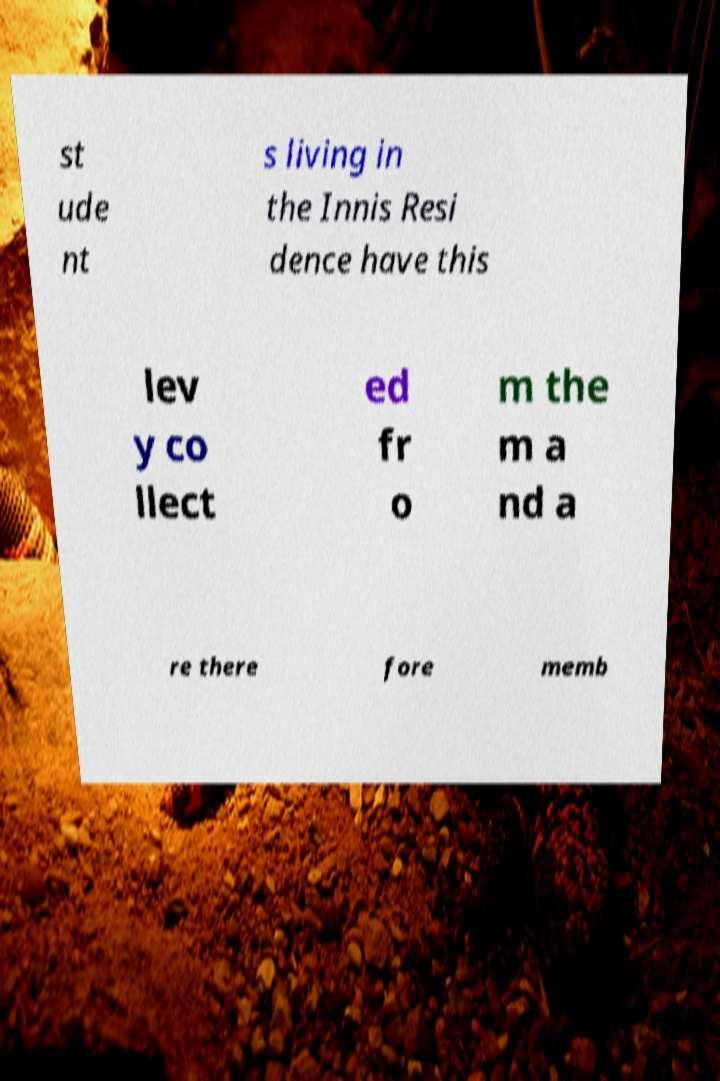Could you extract and type out the text from this image? st ude nt s living in the Innis Resi dence have this lev y co llect ed fr o m the m a nd a re there fore memb 